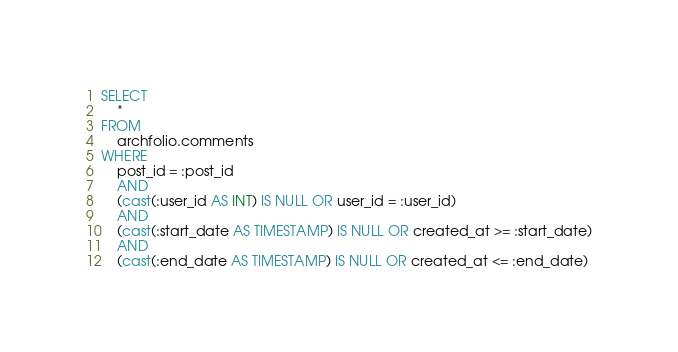<code> <loc_0><loc_0><loc_500><loc_500><_SQL_>SELECT
    *
FROM
    archfolio.comments
WHERE
    post_id = :post_id
    AND
    (cast(:user_id AS INT) IS NULL OR user_id = :user_id)
    AND
    (cast(:start_date AS TIMESTAMP) IS NULL OR created_at >= :start_date)
    AND
    (cast(:end_date AS TIMESTAMP) IS NULL OR created_at <= :end_date)
</code> 